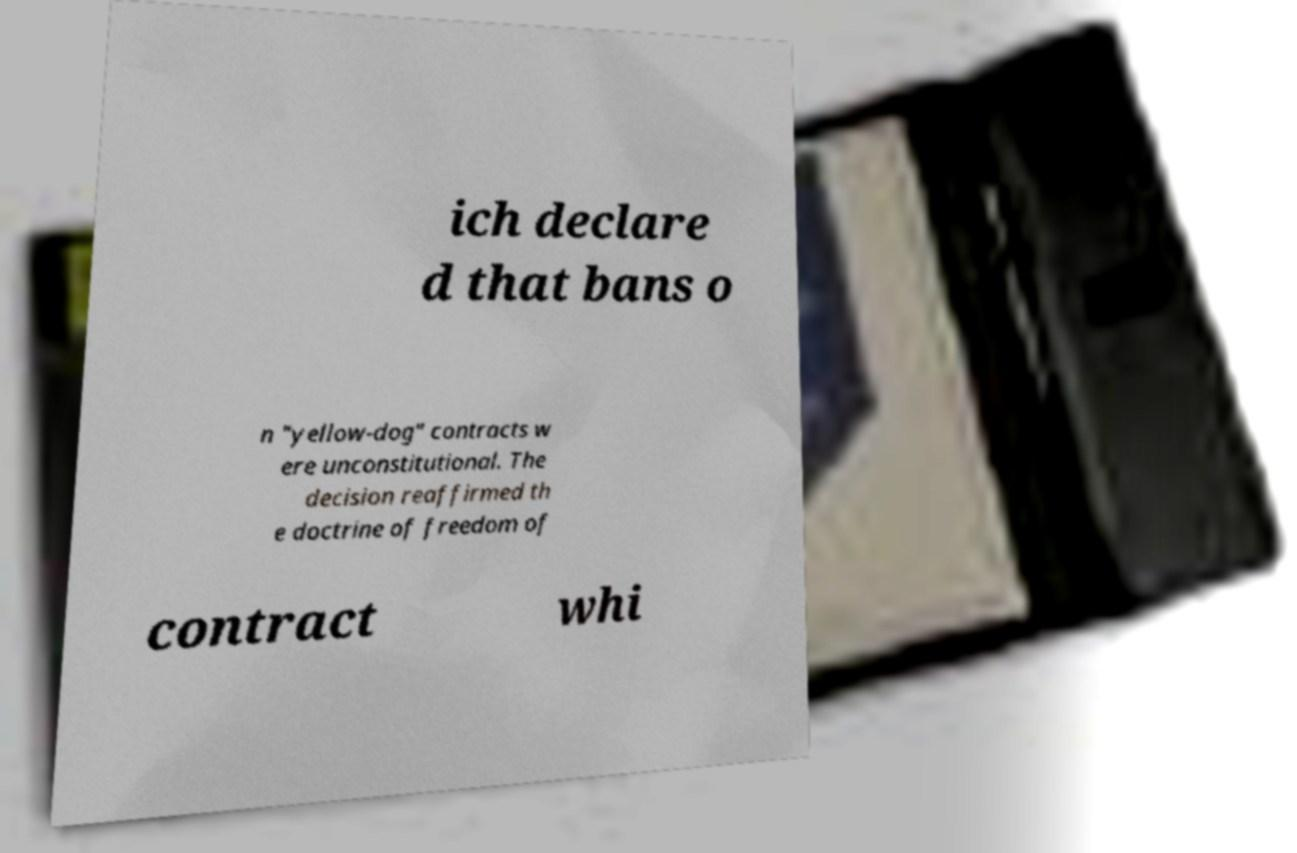Please read and relay the text visible in this image. What does it say? ich declare d that bans o n "yellow-dog" contracts w ere unconstitutional. The decision reaffirmed th e doctrine of freedom of contract whi 